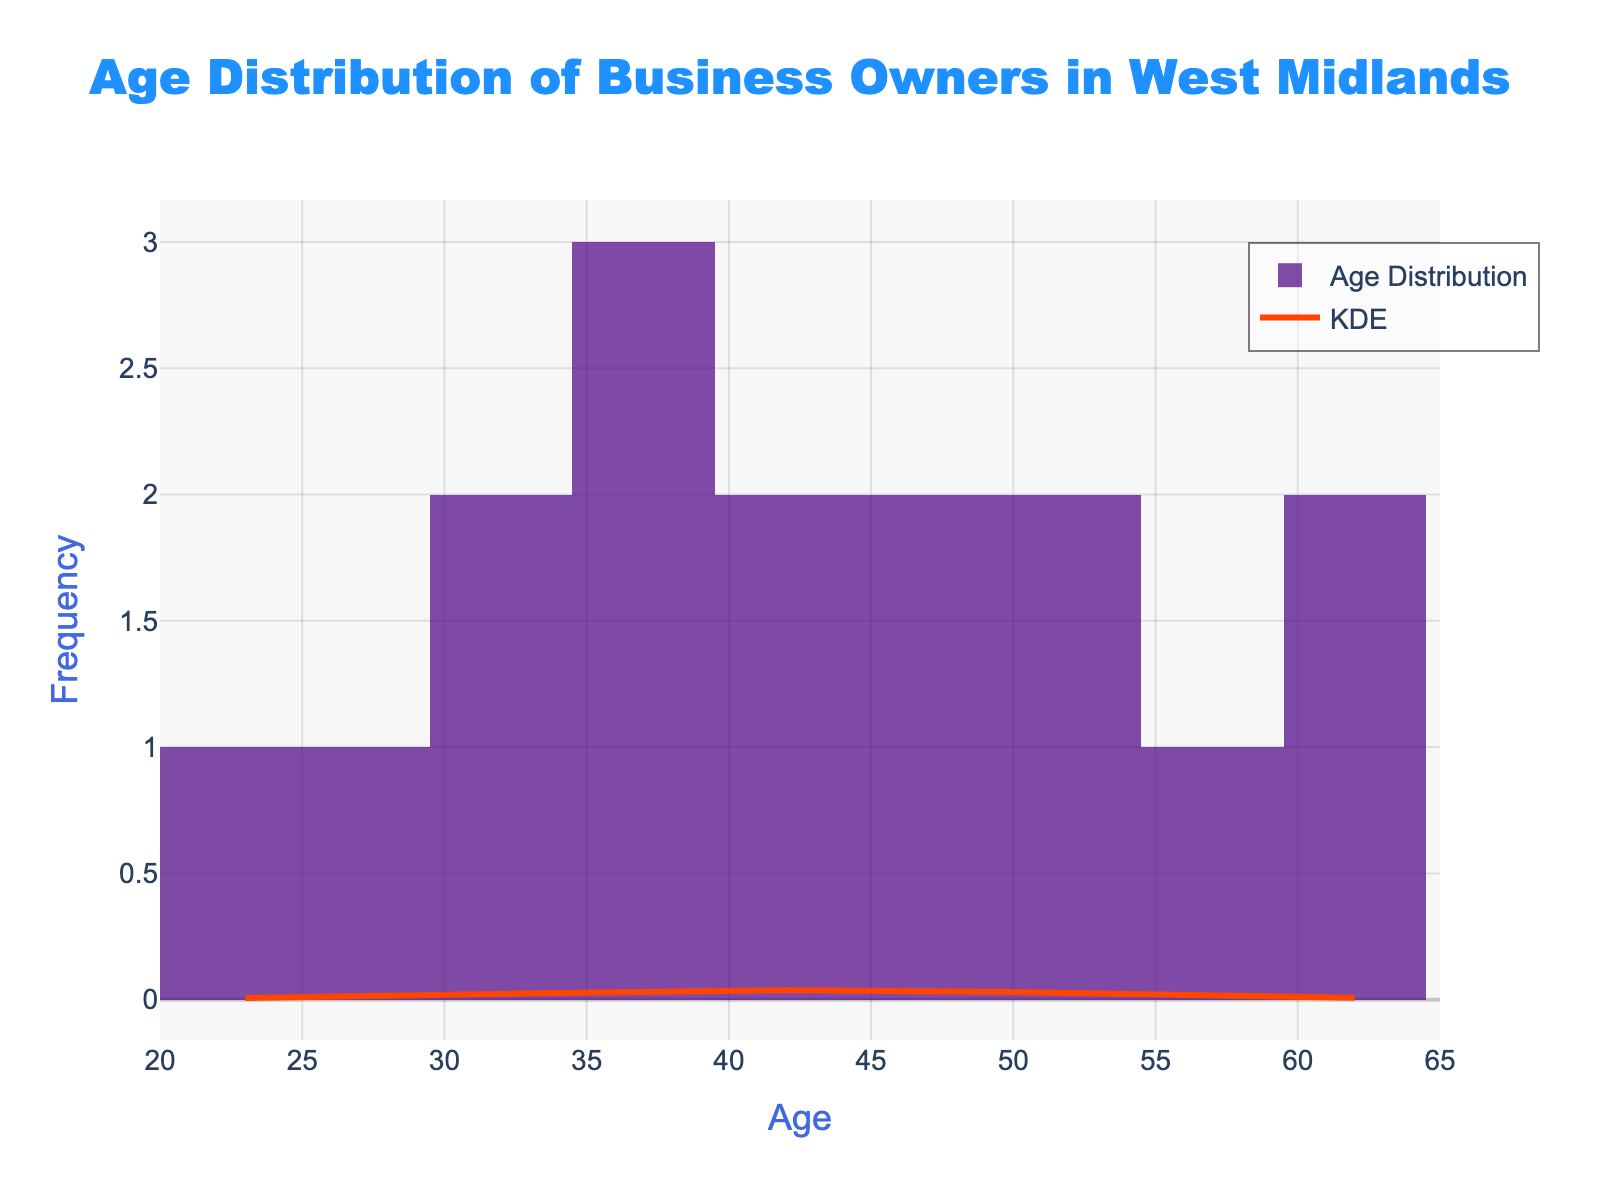what is the title of the plot? The title is located at the top of the plot, and it describes what the graph represents.
Answer: Age Distribution of Business Owners in West Midlands what does the x-axis represent? The x-axis label is provided at the bottom of the plot, indicating what the horizontal axis measures.
Answer: Age what is the primary color of the histogram bars? By examining the histogram bars, we can see their color, which is visually consistent across all bars.
Answer: Purple how many business owners are aged between 40 and 50? Count the bars that span the age range from 40 to 50 and sum their frequencies.
Answer: 5 which age group has the highest frequency of business owners? Identify the tallest histogram bar and note the corresponding age range below it.
Answer: 46-50 what is the approximate value of the KDE peak? The highest point on the KDE curve represents its peak value, which can be observed and approximated from the y-axis.
Answer: around 0.02 how does the age distribution curve behave around age 60? Observe the KDE curve near age 60 to see if it rises, peaks, or falls.
Answer: Falls are there any age groups with no business owners at all? Check if there are segments of the x-axis with no histogram bars at all.
Answer: No what is the average age of the business owners? The mean age can be inferred from the midpoint of the KDE curve, which is approximately centered on the average value.
Answer: around 42-44 